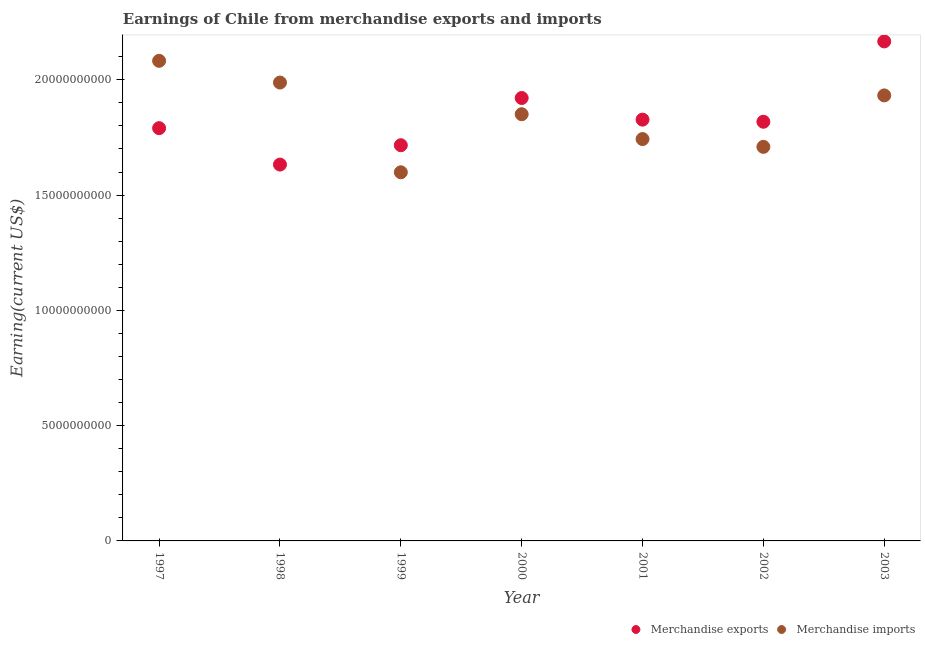How many different coloured dotlines are there?
Your answer should be compact. 2. Is the number of dotlines equal to the number of legend labels?
Keep it short and to the point. Yes. What is the earnings from merchandise imports in 1998?
Keep it short and to the point. 1.99e+1. Across all years, what is the maximum earnings from merchandise exports?
Make the answer very short. 2.17e+1. Across all years, what is the minimum earnings from merchandise exports?
Offer a terse response. 1.63e+1. In which year was the earnings from merchandise exports maximum?
Your answer should be compact. 2003. In which year was the earnings from merchandise exports minimum?
Give a very brief answer. 1998. What is the total earnings from merchandise imports in the graph?
Keep it short and to the point. 1.29e+11. What is the difference between the earnings from merchandise imports in 1997 and that in 1998?
Your answer should be very brief. 9.42e+08. What is the difference between the earnings from merchandise exports in 2001 and the earnings from merchandise imports in 2000?
Offer a terse response. -2.35e+08. What is the average earnings from merchandise imports per year?
Offer a terse response. 1.84e+1. In the year 2000, what is the difference between the earnings from merchandise exports and earnings from merchandise imports?
Your answer should be compact. 7.03e+08. What is the ratio of the earnings from merchandise exports in 1997 to that in 2003?
Ensure brevity in your answer.  0.83. What is the difference between the highest and the second highest earnings from merchandise exports?
Offer a terse response. 2.45e+09. What is the difference between the highest and the lowest earnings from merchandise exports?
Your answer should be compact. 5.34e+09. Is the sum of the earnings from merchandise imports in 1999 and 2003 greater than the maximum earnings from merchandise exports across all years?
Your answer should be very brief. Yes. Does the earnings from merchandise imports monotonically increase over the years?
Keep it short and to the point. No. How many dotlines are there?
Ensure brevity in your answer.  2. What is the difference between two consecutive major ticks on the Y-axis?
Ensure brevity in your answer.  5.00e+09. What is the title of the graph?
Make the answer very short. Earnings of Chile from merchandise exports and imports. What is the label or title of the Y-axis?
Offer a very short reply. Earning(current US$). What is the Earning(current US$) of Merchandise exports in 1997?
Your answer should be compact. 1.79e+1. What is the Earning(current US$) in Merchandise imports in 1997?
Provide a succinct answer. 2.08e+1. What is the Earning(current US$) of Merchandise exports in 1998?
Provide a succinct answer. 1.63e+1. What is the Earning(current US$) of Merchandise imports in 1998?
Provide a short and direct response. 1.99e+1. What is the Earning(current US$) in Merchandise exports in 1999?
Offer a terse response. 1.72e+1. What is the Earning(current US$) in Merchandise imports in 1999?
Provide a short and direct response. 1.60e+1. What is the Earning(current US$) in Merchandise exports in 2000?
Your response must be concise. 1.92e+1. What is the Earning(current US$) in Merchandise imports in 2000?
Offer a very short reply. 1.85e+1. What is the Earning(current US$) in Merchandise exports in 2001?
Ensure brevity in your answer.  1.83e+1. What is the Earning(current US$) in Merchandise imports in 2001?
Provide a short and direct response. 1.74e+1. What is the Earning(current US$) of Merchandise exports in 2002?
Ensure brevity in your answer.  1.82e+1. What is the Earning(current US$) of Merchandise imports in 2002?
Make the answer very short. 1.71e+1. What is the Earning(current US$) of Merchandise exports in 2003?
Keep it short and to the point. 2.17e+1. What is the Earning(current US$) of Merchandise imports in 2003?
Make the answer very short. 1.93e+1. Across all years, what is the maximum Earning(current US$) of Merchandise exports?
Offer a very short reply. 2.17e+1. Across all years, what is the maximum Earning(current US$) in Merchandise imports?
Keep it short and to the point. 2.08e+1. Across all years, what is the minimum Earning(current US$) of Merchandise exports?
Give a very brief answer. 1.63e+1. Across all years, what is the minimum Earning(current US$) of Merchandise imports?
Provide a short and direct response. 1.60e+1. What is the total Earning(current US$) in Merchandise exports in the graph?
Provide a succinct answer. 1.29e+11. What is the total Earning(current US$) of Merchandise imports in the graph?
Your answer should be compact. 1.29e+11. What is the difference between the Earning(current US$) in Merchandise exports in 1997 and that in 1998?
Ensure brevity in your answer.  1.58e+09. What is the difference between the Earning(current US$) of Merchandise imports in 1997 and that in 1998?
Provide a succinct answer. 9.42e+08. What is the difference between the Earning(current US$) in Merchandise exports in 1997 and that in 1999?
Your answer should be compact. 7.40e+08. What is the difference between the Earning(current US$) of Merchandise imports in 1997 and that in 1999?
Your response must be concise. 4.83e+09. What is the difference between the Earning(current US$) in Merchandise exports in 1997 and that in 2000?
Make the answer very short. -1.31e+09. What is the difference between the Earning(current US$) in Merchandise imports in 1997 and that in 2000?
Your answer should be very brief. 2.32e+09. What is the difference between the Earning(current US$) in Merchandise exports in 1997 and that in 2001?
Ensure brevity in your answer.  -3.70e+08. What is the difference between the Earning(current US$) in Merchandise imports in 1997 and that in 2001?
Make the answer very short. 3.39e+09. What is the difference between the Earning(current US$) of Merchandise exports in 1997 and that in 2002?
Your answer should be very brief. -2.78e+08. What is the difference between the Earning(current US$) in Merchandise imports in 1997 and that in 2002?
Your answer should be compact. 3.73e+09. What is the difference between the Earning(current US$) of Merchandise exports in 1997 and that in 2003?
Keep it short and to the point. -3.76e+09. What is the difference between the Earning(current US$) in Merchandise imports in 1997 and that in 2003?
Give a very brief answer. 1.50e+09. What is the difference between the Earning(current US$) of Merchandise exports in 1998 and that in 1999?
Provide a short and direct response. -8.39e+08. What is the difference between the Earning(current US$) in Merchandise imports in 1998 and that in 1999?
Give a very brief answer. 3.89e+09. What is the difference between the Earning(current US$) of Merchandise exports in 1998 and that in 2000?
Your answer should be compact. -2.89e+09. What is the difference between the Earning(current US$) of Merchandise imports in 1998 and that in 2000?
Your response must be concise. 1.37e+09. What is the difference between the Earning(current US$) of Merchandise exports in 1998 and that in 2001?
Your response must be concise. -1.95e+09. What is the difference between the Earning(current US$) in Merchandise imports in 1998 and that in 2001?
Provide a succinct answer. 2.45e+09. What is the difference between the Earning(current US$) of Merchandise exports in 1998 and that in 2002?
Offer a terse response. -1.86e+09. What is the difference between the Earning(current US$) of Merchandise imports in 1998 and that in 2002?
Your response must be concise. 2.79e+09. What is the difference between the Earning(current US$) in Merchandise exports in 1998 and that in 2003?
Ensure brevity in your answer.  -5.34e+09. What is the difference between the Earning(current US$) of Merchandise imports in 1998 and that in 2003?
Provide a succinct answer. 5.58e+08. What is the difference between the Earning(current US$) of Merchandise exports in 1999 and that in 2000?
Provide a short and direct response. -2.05e+09. What is the difference between the Earning(current US$) of Merchandise imports in 1999 and that in 2000?
Offer a terse response. -2.52e+09. What is the difference between the Earning(current US$) of Merchandise exports in 1999 and that in 2001?
Keep it short and to the point. -1.11e+09. What is the difference between the Earning(current US$) in Merchandise imports in 1999 and that in 2001?
Your answer should be compact. -1.44e+09. What is the difference between the Earning(current US$) in Merchandise exports in 1999 and that in 2002?
Keep it short and to the point. -1.02e+09. What is the difference between the Earning(current US$) of Merchandise imports in 1999 and that in 2002?
Make the answer very short. -1.10e+09. What is the difference between the Earning(current US$) of Merchandise exports in 1999 and that in 2003?
Your response must be concise. -4.50e+09. What is the difference between the Earning(current US$) of Merchandise imports in 1999 and that in 2003?
Offer a terse response. -3.33e+09. What is the difference between the Earning(current US$) in Merchandise exports in 2000 and that in 2001?
Your answer should be very brief. 9.38e+08. What is the difference between the Earning(current US$) in Merchandise imports in 2000 and that in 2001?
Your answer should be compact. 1.08e+09. What is the difference between the Earning(current US$) in Merchandise exports in 2000 and that in 2002?
Offer a terse response. 1.03e+09. What is the difference between the Earning(current US$) in Merchandise imports in 2000 and that in 2002?
Give a very brief answer. 1.42e+09. What is the difference between the Earning(current US$) of Merchandise exports in 2000 and that in 2003?
Provide a succinct answer. -2.45e+09. What is the difference between the Earning(current US$) in Merchandise imports in 2000 and that in 2003?
Give a very brief answer. -8.15e+08. What is the difference between the Earning(current US$) of Merchandise exports in 2001 and that in 2002?
Your answer should be very brief. 9.20e+07. What is the difference between the Earning(current US$) in Merchandise imports in 2001 and that in 2002?
Provide a succinct answer. 3.38e+08. What is the difference between the Earning(current US$) of Merchandise exports in 2001 and that in 2003?
Provide a short and direct response. -3.39e+09. What is the difference between the Earning(current US$) of Merchandise imports in 2001 and that in 2003?
Give a very brief answer. -1.89e+09. What is the difference between the Earning(current US$) of Merchandise exports in 2002 and that in 2003?
Make the answer very short. -3.48e+09. What is the difference between the Earning(current US$) of Merchandise imports in 2002 and that in 2003?
Keep it short and to the point. -2.23e+09. What is the difference between the Earning(current US$) of Merchandise exports in 1997 and the Earning(current US$) of Merchandise imports in 1998?
Keep it short and to the point. -1.98e+09. What is the difference between the Earning(current US$) in Merchandise exports in 1997 and the Earning(current US$) in Merchandise imports in 1999?
Keep it short and to the point. 1.91e+09. What is the difference between the Earning(current US$) of Merchandise exports in 1997 and the Earning(current US$) of Merchandise imports in 2000?
Make the answer very short. -6.05e+08. What is the difference between the Earning(current US$) of Merchandise exports in 1997 and the Earning(current US$) of Merchandise imports in 2001?
Make the answer very short. 4.73e+08. What is the difference between the Earning(current US$) in Merchandise exports in 1997 and the Earning(current US$) in Merchandise imports in 2002?
Offer a very short reply. 8.11e+08. What is the difference between the Earning(current US$) in Merchandise exports in 1997 and the Earning(current US$) in Merchandise imports in 2003?
Provide a succinct answer. -1.42e+09. What is the difference between the Earning(current US$) in Merchandise exports in 1998 and the Earning(current US$) in Merchandise imports in 1999?
Your response must be concise. 3.35e+08. What is the difference between the Earning(current US$) in Merchandise exports in 1998 and the Earning(current US$) in Merchandise imports in 2000?
Give a very brief answer. -2.18e+09. What is the difference between the Earning(current US$) in Merchandise exports in 1998 and the Earning(current US$) in Merchandise imports in 2001?
Ensure brevity in your answer.  -1.11e+09. What is the difference between the Earning(current US$) of Merchandise exports in 1998 and the Earning(current US$) of Merchandise imports in 2002?
Make the answer very short. -7.68e+08. What is the difference between the Earning(current US$) in Merchandise exports in 1998 and the Earning(current US$) in Merchandise imports in 2003?
Offer a very short reply. -3.00e+09. What is the difference between the Earning(current US$) in Merchandise exports in 1999 and the Earning(current US$) in Merchandise imports in 2000?
Provide a short and direct response. -1.34e+09. What is the difference between the Earning(current US$) of Merchandise exports in 1999 and the Earning(current US$) of Merchandise imports in 2001?
Offer a terse response. -2.67e+08. What is the difference between the Earning(current US$) of Merchandise exports in 1999 and the Earning(current US$) of Merchandise imports in 2002?
Offer a terse response. 7.10e+07. What is the difference between the Earning(current US$) of Merchandise exports in 1999 and the Earning(current US$) of Merchandise imports in 2003?
Your answer should be compact. -2.16e+09. What is the difference between the Earning(current US$) in Merchandise exports in 2000 and the Earning(current US$) in Merchandise imports in 2001?
Your answer should be compact. 1.78e+09. What is the difference between the Earning(current US$) of Merchandise exports in 2000 and the Earning(current US$) of Merchandise imports in 2002?
Provide a succinct answer. 2.12e+09. What is the difference between the Earning(current US$) of Merchandise exports in 2000 and the Earning(current US$) of Merchandise imports in 2003?
Keep it short and to the point. -1.12e+08. What is the difference between the Earning(current US$) in Merchandise exports in 2001 and the Earning(current US$) in Merchandise imports in 2002?
Keep it short and to the point. 1.18e+09. What is the difference between the Earning(current US$) of Merchandise exports in 2001 and the Earning(current US$) of Merchandise imports in 2003?
Provide a short and direct response. -1.05e+09. What is the difference between the Earning(current US$) of Merchandise exports in 2002 and the Earning(current US$) of Merchandise imports in 2003?
Your response must be concise. -1.14e+09. What is the average Earning(current US$) in Merchandise exports per year?
Your answer should be compact. 1.84e+1. What is the average Earning(current US$) in Merchandise imports per year?
Offer a very short reply. 1.84e+1. In the year 1997, what is the difference between the Earning(current US$) in Merchandise exports and Earning(current US$) in Merchandise imports?
Ensure brevity in your answer.  -2.92e+09. In the year 1998, what is the difference between the Earning(current US$) of Merchandise exports and Earning(current US$) of Merchandise imports?
Keep it short and to the point. -3.56e+09. In the year 1999, what is the difference between the Earning(current US$) of Merchandise exports and Earning(current US$) of Merchandise imports?
Offer a very short reply. 1.17e+09. In the year 2000, what is the difference between the Earning(current US$) in Merchandise exports and Earning(current US$) in Merchandise imports?
Your answer should be very brief. 7.03e+08. In the year 2001, what is the difference between the Earning(current US$) in Merchandise exports and Earning(current US$) in Merchandise imports?
Your answer should be very brief. 8.43e+08. In the year 2002, what is the difference between the Earning(current US$) in Merchandise exports and Earning(current US$) in Merchandise imports?
Ensure brevity in your answer.  1.09e+09. In the year 2003, what is the difference between the Earning(current US$) of Merchandise exports and Earning(current US$) of Merchandise imports?
Make the answer very short. 2.34e+09. What is the ratio of the Earning(current US$) of Merchandise exports in 1997 to that in 1998?
Provide a succinct answer. 1.1. What is the ratio of the Earning(current US$) of Merchandise imports in 1997 to that in 1998?
Offer a terse response. 1.05. What is the ratio of the Earning(current US$) of Merchandise exports in 1997 to that in 1999?
Offer a very short reply. 1.04. What is the ratio of the Earning(current US$) in Merchandise imports in 1997 to that in 1999?
Ensure brevity in your answer.  1.3. What is the ratio of the Earning(current US$) of Merchandise exports in 1997 to that in 2000?
Provide a short and direct response. 0.93. What is the ratio of the Earning(current US$) of Merchandise imports in 1997 to that in 2000?
Offer a very short reply. 1.13. What is the ratio of the Earning(current US$) in Merchandise exports in 1997 to that in 2001?
Your response must be concise. 0.98. What is the ratio of the Earning(current US$) of Merchandise imports in 1997 to that in 2001?
Offer a very short reply. 1.19. What is the ratio of the Earning(current US$) of Merchandise exports in 1997 to that in 2002?
Provide a succinct answer. 0.98. What is the ratio of the Earning(current US$) in Merchandise imports in 1997 to that in 2002?
Offer a very short reply. 1.22. What is the ratio of the Earning(current US$) of Merchandise exports in 1997 to that in 2003?
Your answer should be compact. 0.83. What is the ratio of the Earning(current US$) of Merchandise imports in 1997 to that in 2003?
Provide a short and direct response. 1.08. What is the ratio of the Earning(current US$) of Merchandise exports in 1998 to that in 1999?
Your answer should be compact. 0.95. What is the ratio of the Earning(current US$) in Merchandise imports in 1998 to that in 1999?
Your response must be concise. 1.24. What is the ratio of the Earning(current US$) in Merchandise exports in 1998 to that in 2000?
Make the answer very short. 0.85. What is the ratio of the Earning(current US$) of Merchandise imports in 1998 to that in 2000?
Your answer should be compact. 1.07. What is the ratio of the Earning(current US$) in Merchandise exports in 1998 to that in 2001?
Keep it short and to the point. 0.89. What is the ratio of the Earning(current US$) in Merchandise imports in 1998 to that in 2001?
Provide a short and direct response. 1.14. What is the ratio of the Earning(current US$) of Merchandise exports in 1998 to that in 2002?
Offer a terse response. 0.9. What is the ratio of the Earning(current US$) in Merchandise imports in 1998 to that in 2002?
Your response must be concise. 1.16. What is the ratio of the Earning(current US$) in Merchandise exports in 1998 to that in 2003?
Your answer should be compact. 0.75. What is the ratio of the Earning(current US$) in Merchandise imports in 1998 to that in 2003?
Give a very brief answer. 1.03. What is the ratio of the Earning(current US$) of Merchandise exports in 1999 to that in 2000?
Offer a very short reply. 0.89. What is the ratio of the Earning(current US$) of Merchandise imports in 1999 to that in 2000?
Provide a succinct answer. 0.86. What is the ratio of the Earning(current US$) of Merchandise exports in 1999 to that in 2001?
Give a very brief answer. 0.94. What is the ratio of the Earning(current US$) in Merchandise imports in 1999 to that in 2001?
Your answer should be very brief. 0.92. What is the ratio of the Earning(current US$) of Merchandise exports in 1999 to that in 2002?
Keep it short and to the point. 0.94. What is the ratio of the Earning(current US$) of Merchandise imports in 1999 to that in 2002?
Ensure brevity in your answer.  0.94. What is the ratio of the Earning(current US$) in Merchandise exports in 1999 to that in 2003?
Give a very brief answer. 0.79. What is the ratio of the Earning(current US$) of Merchandise imports in 1999 to that in 2003?
Provide a short and direct response. 0.83. What is the ratio of the Earning(current US$) in Merchandise exports in 2000 to that in 2001?
Offer a terse response. 1.05. What is the ratio of the Earning(current US$) in Merchandise imports in 2000 to that in 2001?
Give a very brief answer. 1.06. What is the ratio of the Earning(current US$) of Merchandise exports in 2000 to that in 2002?
Keep it short and to the point. 1.06. What is the ratio of the Earning(current US$) in Merchandise imports in 2000 to that in 2002?
Make the answer very short. 1.08. What is the ratio of the Earning(current US$) of Merchandise exports in 2000 to that in 2003?
Provide a succinct answer. 0.89. What is the ratio of the Earning(current US$) of Merchandise imports in 2000 to that in 2003?
Your answer should be compact. 0.96. What is the ratio of the Earning(current US$) of Merchandise exports in 2001 to that in 2002?
Provide a short and direct response. 1.01. What is the ratio of the Earning(current US$) of Merchandise imports in 2001 to that in 2002?
Keep it short and to the point. 1.02. What is the ratio of the Earning(current US$) of Merchandise exports in 2001 to that in 2003?
Make the answer very short. 0.84. What is the ratio of the Earning(current US$) of Merchandise imports in 2001 to that in 2003?
Make the answer very short. 0.9. What is the ratio of the Earning(current US$) in Merchandise exports in 2002 to that in 2003?
Your response must be concise. 0.84. What is the ratio of the Earning(current US$) of Merchandise imports in 2002 to that in 2003?
Your answer should be very brief. 0.88. What is the difference between the highest and the second highest Earning(current US$) in Merchandise exports?
Your response must be concise. 2.45e+09. What is the difference between the highest and the second highest Earning(current US$) of Merchandise imports?
Provide a succinct answer. 9.42e+08. What is the difference between the highest and the lowest Earning(current US$) of Merchandise exports?
Offer a terse response. 5.34e+09. What is the difference between the highest and the lowest Earning(current US$) of Merchandise imports?
Your answer should be compact. 4.83e+09. 